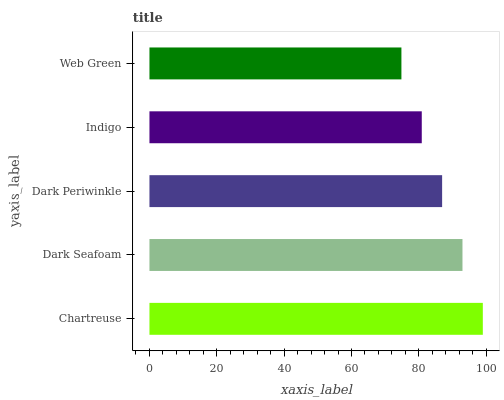Is Web Green the minimum?
Answer yes or no. Yes. Is Chartreuse the maximum?
Answer yes or no. Yes. Is Dark Seafoam the minimum?
Answer yes or no. No. Is Dark Seafoam the maximum?
Answer yes or no. No. Is Chartreuse greater than Dark Seafoam?
Answer yes or no. Yes. Is Dark Seafoam less than Chartreuse?
Answer yes or no. Yes. Is Dark Seafoam greater than Chartreuse?
Answer yes or no. No. Is Chartreuse less than Dark Seafoam?
Answer yes or no. No. Is Dark Periwinkle the high median?
Answer yes or no. Yes. Is Dark Periwinkle the low median?
Answer yes or no. Yes. Is Indigo the high median?
Answer yes or no. No. Is Dark Seafoam the low median?
Answer yes or no. No. 